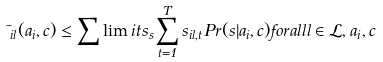<formula> <loc_0><loc_0><loc_500><loc_500>\mu _ { i l } ( a _ { i } , c ) \leq \sum \lim i t s _ { s } \sum _ { t = 1 } ^ { T } s _ { i l , t } P r ( s | a _ { i } , c ) f o r a l l l \in \mathcal { L } , a _ { i } , c</formula> 